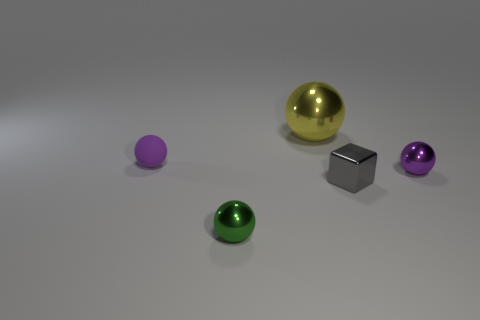Subtract all yellow balls. Subtract all green cylinders. How many balls are left? 3 Add 4 large red cylinders. How many objects exist? 9 Subtract all balls. How many objects are left? 1 Subtract 0 purple cubes. How many objects are left? 5 Subtract all blue rubber cylinders. Subtract all small purple metallic things. How many objects are left? 4 Add 4 yellow balls. How many yellow balls are left? 5 Add 3 blue rubber objects. How many blue rubber objects exist? 3 